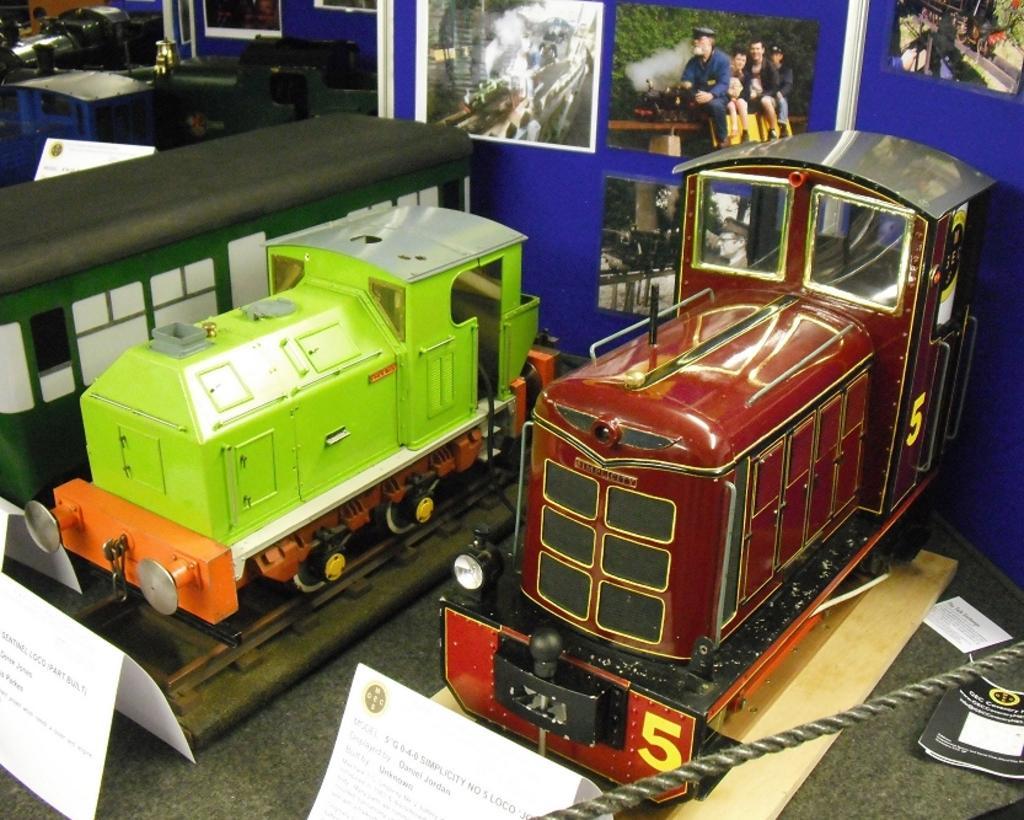Can you describe this image briefly? Here in this picture we can see train engine toys present on the floor over there and in the front we can see a rope present and we can see papers and books present on floor here and there and on the wall we can see photos stuck here and there. 